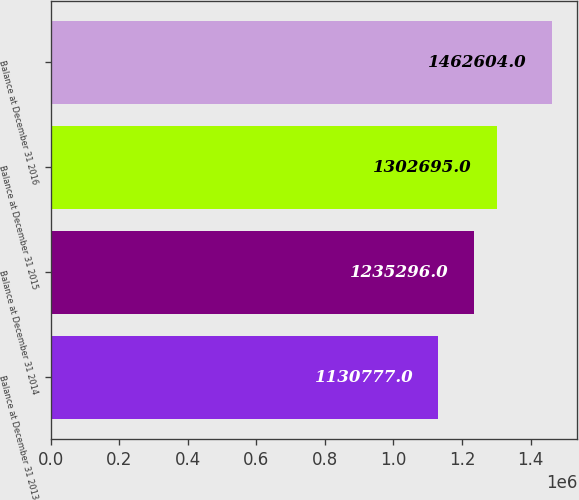Convert chart to OTSL. <chart><loc_0><loc_0><loc_500><loc_500><bar_chart><fcel>Balance at December 31 2013<fcel>Balance at December 31 2014<fcel>Balance at December 31 2015<fcel>Balance at December 31 2016<nl><fcel>1.13078e+06<fcel>1.2353e+06<fcel>1.3027e+06<fcel>1.4626e+06<nl></chart> 